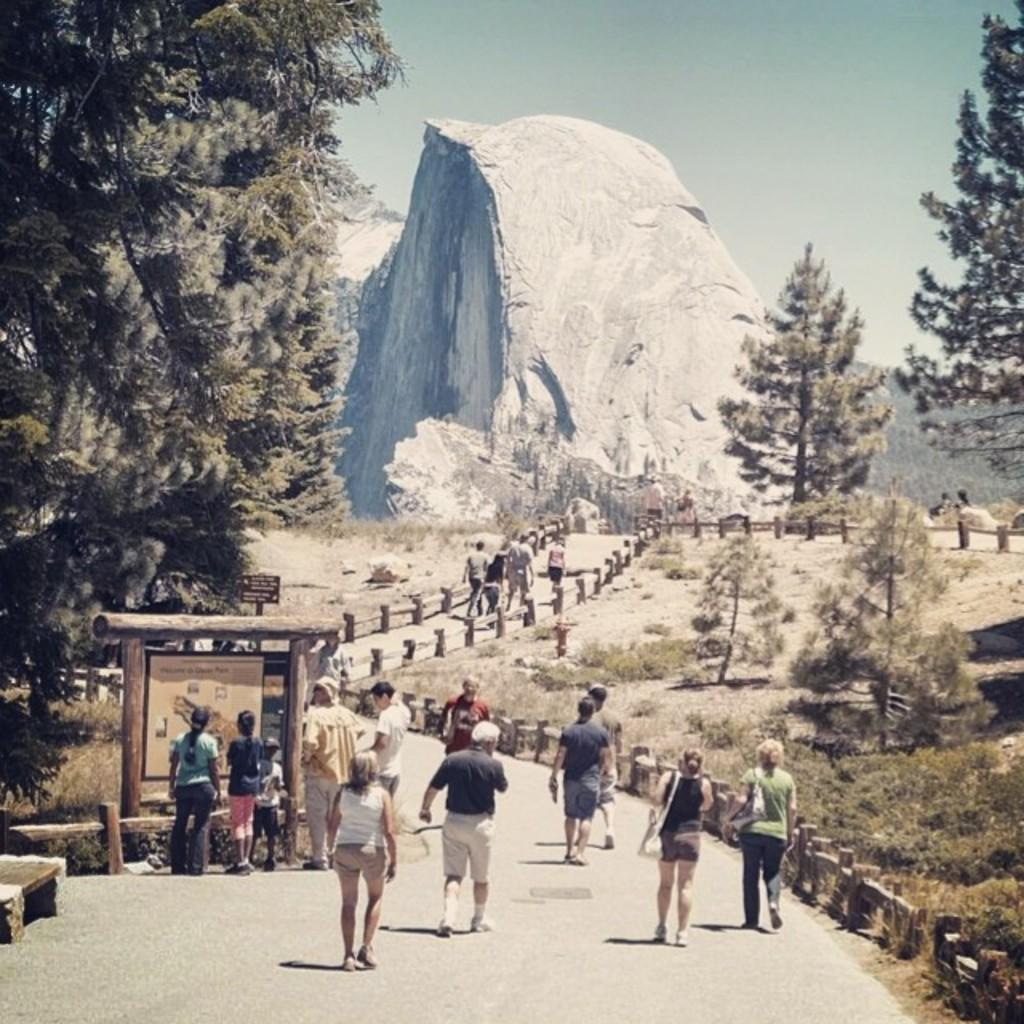Who or what can be seen in the image? There are people in the image. What type of natural elements are present in the image? There are trees and plants in the image. What is the ground like in the image? The ground is visible in the image with some objects. What type of barrier can be seen in the image? There is a fence in the image. What geographical feature is visible in the image? There is a mountain in the image. What part of the natural environment is visible in the image? The sky is visible in the image. What type of pancake is being used as a prop in the image? There is no pancake present in the image. How many sticks are being held by the people in the image? There is no mention of sticks being held by the people in the image. 